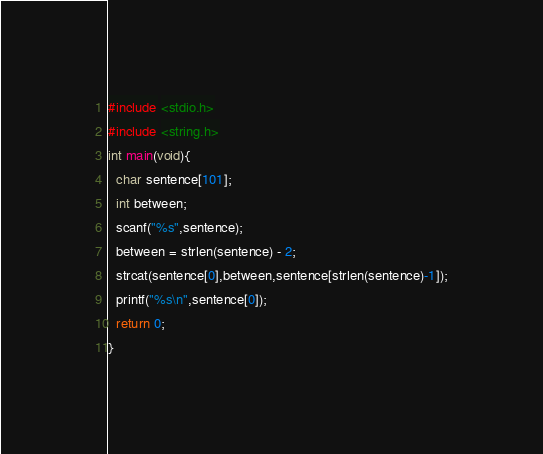Convert code to text. <code><loc_0><loc_0><loc_500><loc_500><_C_>#include <stdio.h>
#include <string.h>
int main(void){
  char sentence[101];
  int between;
  scanf("%s",sentence);
  between = strlen(sentence) - 2;
  strcat(sentence[0],between,sentence[strlen(sentence)-1]);
  printf("%s\n",sentence[0]);
  return 0;
}</code> 